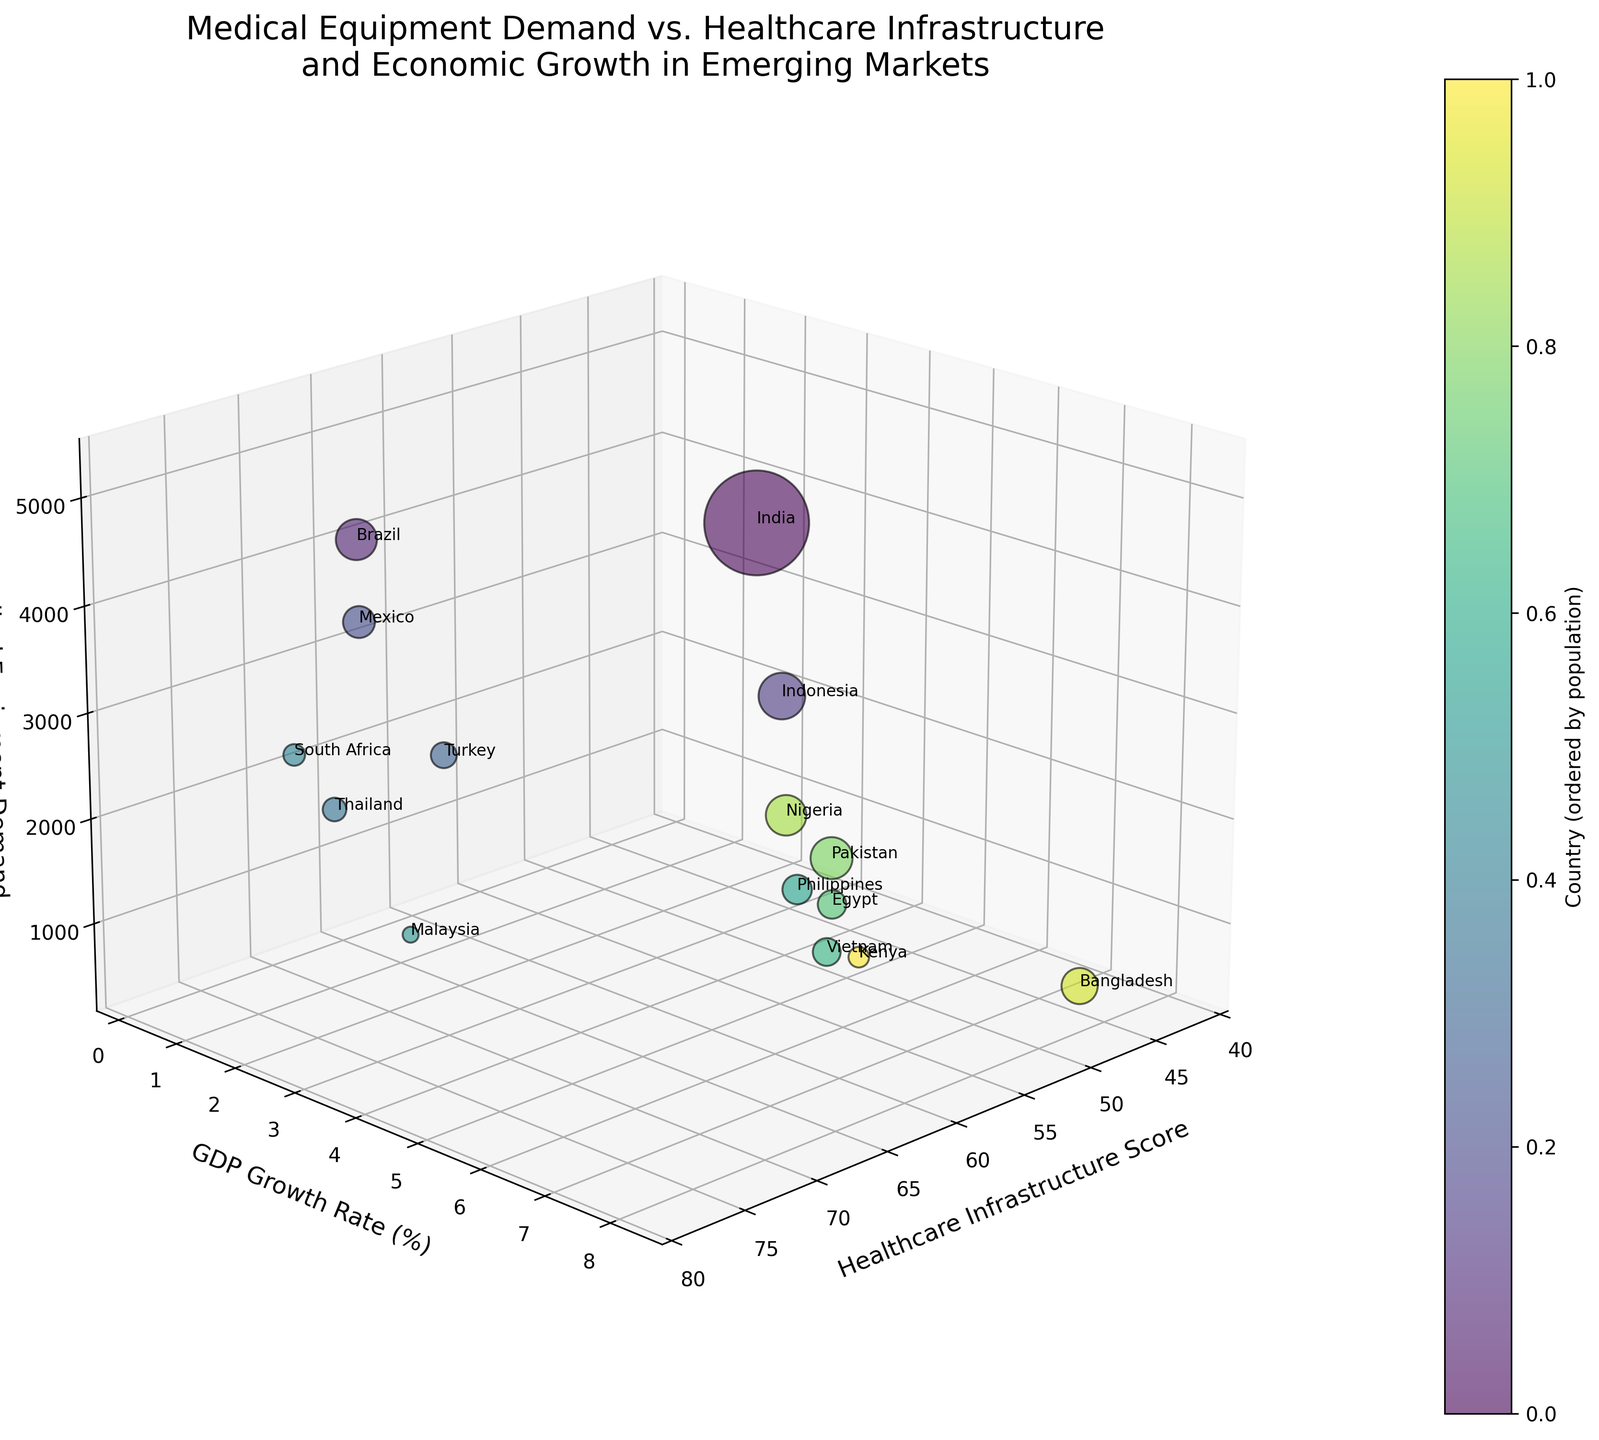What's the title of the plot? The title is located at the top of the plot. It reads "Medical Equipment Demand vs. Healthcare Infrastructure and Economic Growth in Emerging Markets".
Answer: Medical Equipment Demand vs. Healthcare Infrastructure and Economic Growth in Emerging Markets How is the colorbar labeled? The colorbar label is placed next to the colorbar, indicating what it represents. It is labeled "Country (ordered by population)".
Answer: Country (ordered by population) Which country has the highest medical equipment demand? By looking at the z-axis and identifying which bubble is the highest, we can see that India has the highest medical equipment demand.
Answer: India What is the range of healthcare infrastructure scores among the countries? By observing the x-axis, the lowest value is 42, and the highest value is 78.
Answer: 42 to 78 Which country has the lowest GDP growth rate? By checking the lowest value on the y-axis among all the bubbles and finding the corresponding country label, it is South Africa.
Answer: South Africa How does Indonesia's healthcare infrastructure score compare to Mexico's? Indonesia's healthcare infrastructure score is 55, while Mexico's is 68. Therefore, Mexico's score is higher.
Answer: Mexico's is higher Which country with a medical equipment demand greater than 3000 USD millions has the highest GDP growth rate? India (6.1%), Brazil (2.3%), Mexico (1.1%), and Indonesia (5.0%) have medical equipment demand greater than 3000 USD millions. Among them, India has the highest GDP growth rate at 6.1%.
Answer: India What is the average healthcare infrastructure score of countries with a GDP growth rate below 3%? Countries with GDP growth below 3% are Brazil (73), Mexico (68), South Africa (69), and Turkey (71). Their average healthcare infrastructure score is (73+68+69+71)/4 = 70.25.
Answer: 70.25 Which country has the largest bubble, and why? The bubble size represents population. By comparing the bubble sizes, Pakistan has the largest bubble, hence the largest population (221 million).
Answer: Pakistan Do countries with higher healthcare infrastructure scores generally have higher medical equipment demand? By analyzing both the x-axis and z-axis, it appears that there is some correlation, but it is not absolute. For instance, Thailand and Malaysia have high scores and relatively high demand, but India, with a medium score, has the highest demand.
Answer: Some correlation, but not definite 